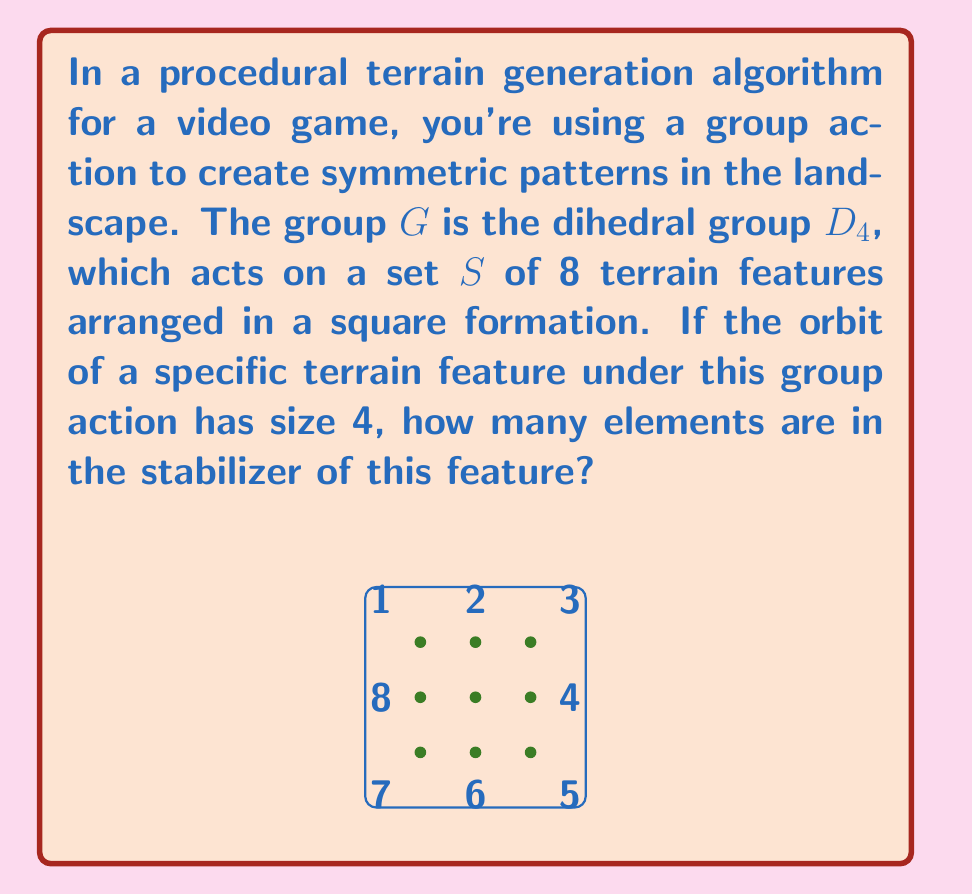Show me your answer to this math problem. Let's approach this step-by-step:

1) First, recall the Orbit-Stabilizer Theorem. For a group $G$ acting on a set $S$, and for any $s \in S$:

   $$|G| = |Orb(s)| \cdot |Stab(s)|$$

   Where $|G|$ is the order of the group, $|Orb(s)|$ is the size of the orbit of $s$, and $|Stab(s)|$ is the size of the stabilizer of $s$.

2) We're given that the group is $D_4$, the dihedral group of order 8. So $|G| = 8$.

3) We're also told that the orbit of the specific terrain feature has size 4. So $|Orb(s)| = 4$.

4) Now we can plug these values into the Orbit-Stabilizer Theorem:

   $$8 = 4 \cdot |Stab(s)|$$

5) Solving for $|Stab(s)|$:

   $$|Stab(s)| = \frac{8}{4} = 2$$

Therefore, the stabilizer of this feature has 2 elements.

In the context of terrain generation, this means that there are 2 symmetry operations in $D_4$ that leave this particular terrain feature unchanged, while the other 6 operations of $D_4$ move it to a different position.
Answer: 2 